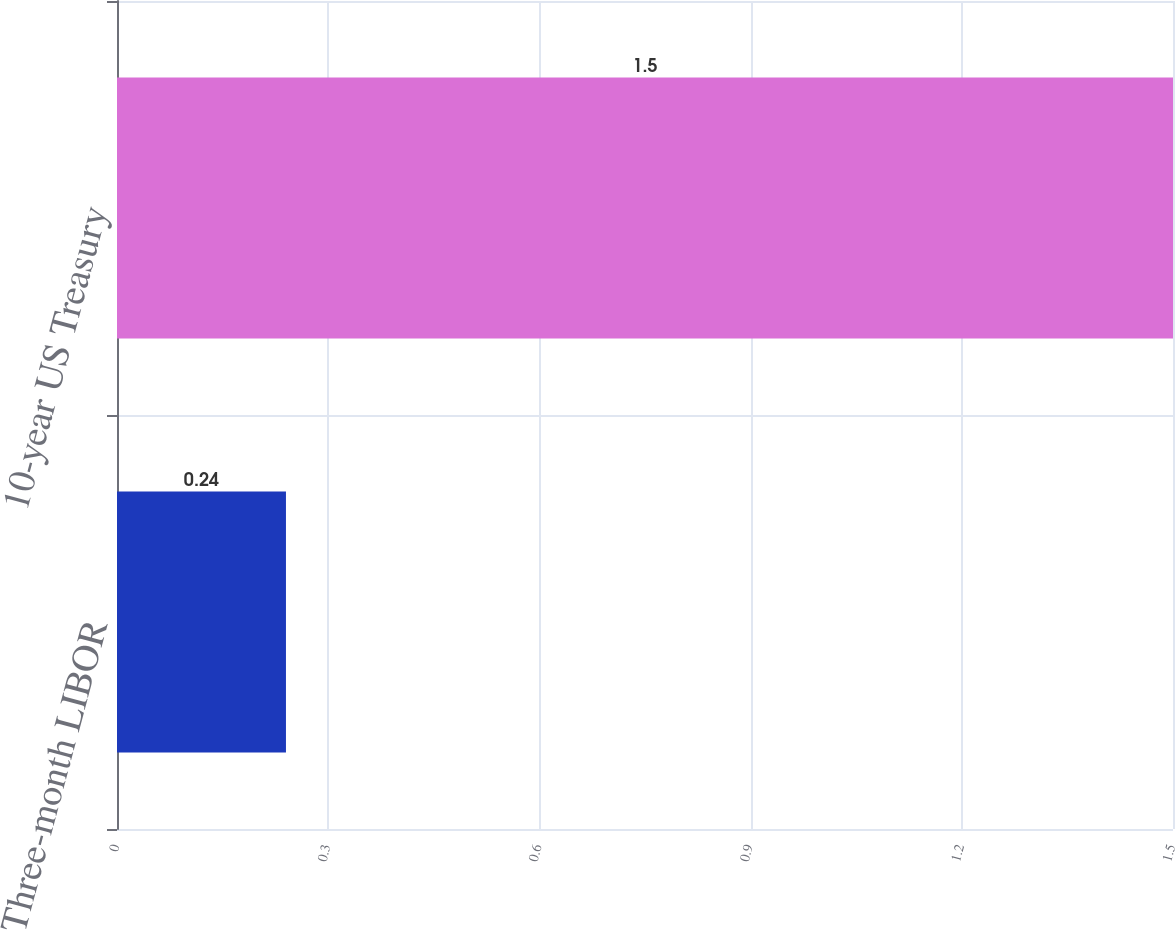Convert chart. <chart><loc_0><loc_0><loc_500><loc_500><bar_chart><fcel>Three-month LIBOR<fcel>10-year US Treasury<nl><fcel>0.24<fcel>1.5<nl></chart> 